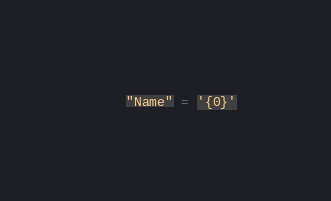<code> <loc_0><loc_0><loc_500><loc_500><_SQL_>    "Name" = '{0}'</code> 